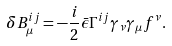Convert formula to latex. <formula><loc_0><loc_0><loc_500><loc_500>\delta B _ { \mu } ^ { i j } = - \frac { i } { 2 } \bar { \epsilon } \Gamma ^ { i j } \gamma _ { \nu } \gamma _ { \mu } f ^ { \nu } .</formula> 